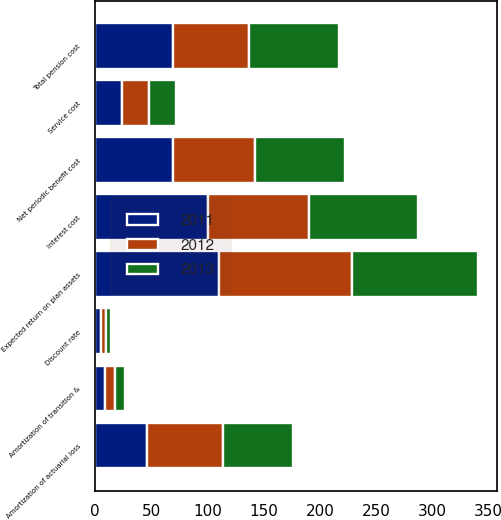Convert chart to OTSL. <chart><loc_0><loc_0><loc_500><loc_500><stacked_bar_chart><ecel><fcel>Service cost<fcel>Interest cost<fcel>Expected return on plan assets<fcel>Amortization of transition &<fcel>Amortization of actuarial loss<fcel>Net periodic benefit cost<fcel>Total pension cost<fcel>Discount rate<nl><fcel>2012<fcel>24<fcel>90<fcel>118<fcel>9<fcel>68<fcel>73<fcel>68<fcel>4.14<nl><fcel>2013<fcel>24<fcel>97<fcel>112<fcel>9<fcel>62<fcel>80<fcel>80<fcel>4.9<nl><fcel>2011<fcel>24<fcel>100<fcel>110<fcel>9<fcel>46<fcel>69<fcel>69<fcel>5.3<nl></chart> 